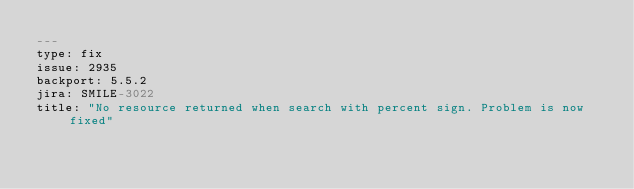<code> <loc_0><loc_0><loc_500><loc_500><_YAML_>---
type: fix
issue: 2935
backport: 5.5.2
jira: SMILE-3022
title: "No resource returned when search with percent sign. Problem is now fixed"
</code> 